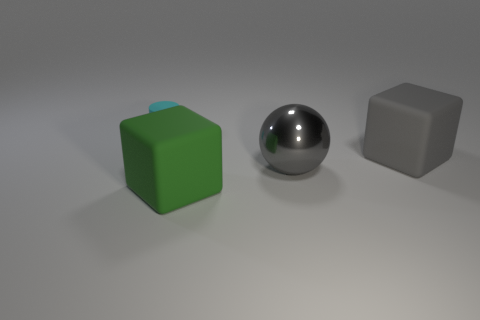What is the size of the cube that is the same color as the large metallic object?
Offer a terse response. Large. What number of other objects are the same size as the gray ball?
Ensure brevity in your answer.  2. Are there any large green rubber things that are on the left side of the large block behind the large block that is in front of the gray metal ball?
Your answer should be compact. Yes. Is there anything else of the same color as the big metal ball?
Provide a short and direct response. Yes. There is a gray object behind the shiny sphere; how big is it?
Offer a very short reply. Large. There is a matte thing on the left side of the big thing that is left of the large gray metallic sphere that is behind the large green rubber block; what is its size?
Provide a succinct answer. Small. There is a large cube in front of the large rubber cube right of the green block; what is its color?
Keep it short and to the point. Green. Is there anything else that has the same material as the large sphere?
Provide a succinct answer. No. There is a large metal sphere; are there any big gray metallic balls to the left of it?
Your answer should be very brief. No. What number of small brown rubber cubes are there?
Offer a terse response. 0. 